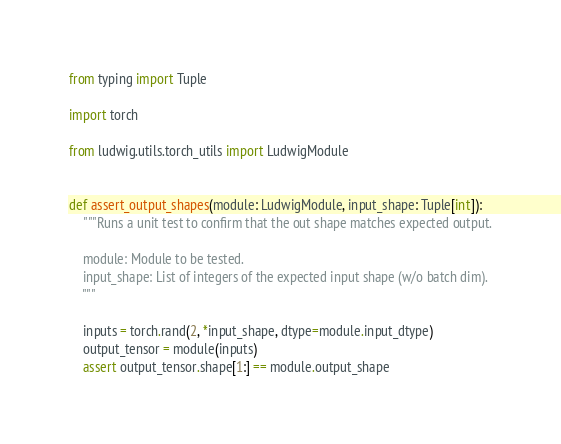Convert code to text. <code><loc_0><loc_0><loc_500><loc_500><_Python_>from typing import Tuple

import torch

from ludwig.utils.torch_utils import LudwigModule


def assert_output_shapes(module: LudwigModule, input_shape: Tuple[int]):
    """Runs a unit test to confirm that the out shape matches expected output.

    module: Module to be tested.
    input_shape: List of integers of the expected input shape (w/o batch dim).
    """

    inputs = torch.rand(2, *input_shape, dtype=module.input_dtype)
    output_tensor = module(inputs)
    assert output_tensor.shape[1:] == module.output_shape
</code> 